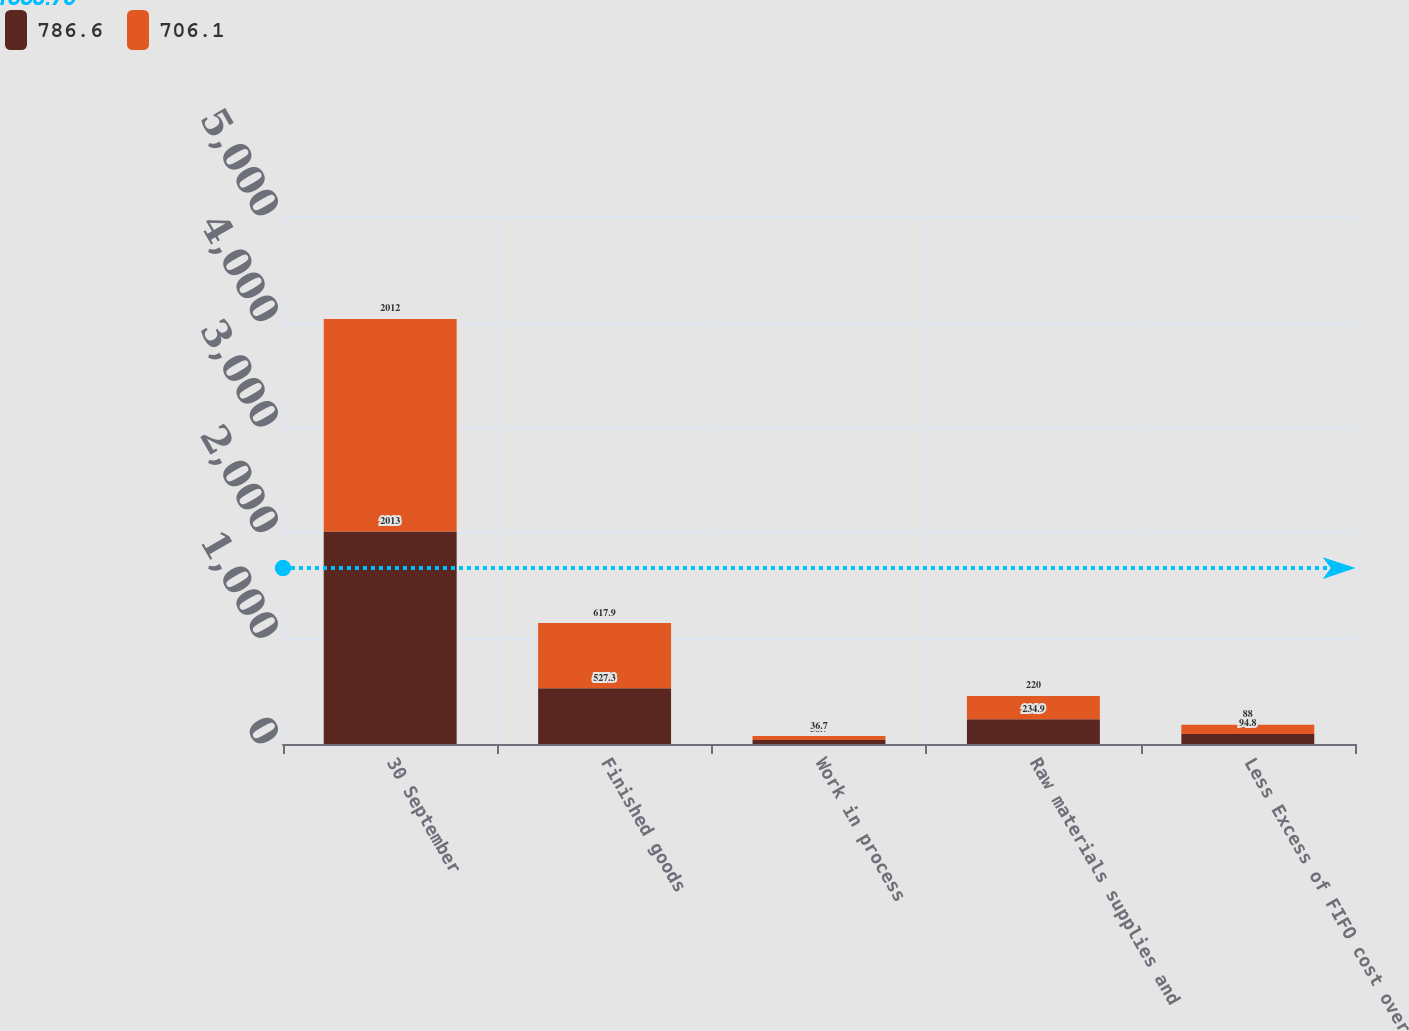<chart> <loc_0><loc_0><loc_500><loc_500><stacked_bar_chart><ecel><fcel>30 September<fcel>Finished goods<fcel>Work in process<fcel>Raw materials supplies and<fcel>Less Excess of FIFO cost over<nl><fcel>786.6<fcel>2013<fcel>527.3<fcel>38.7<fcel>234.9<fcel>94.8<nl><fcel>706.1<fcel>2012<fcel>617.9<fcel>36.7<fcel>220<fcel>88<nl></chart> 